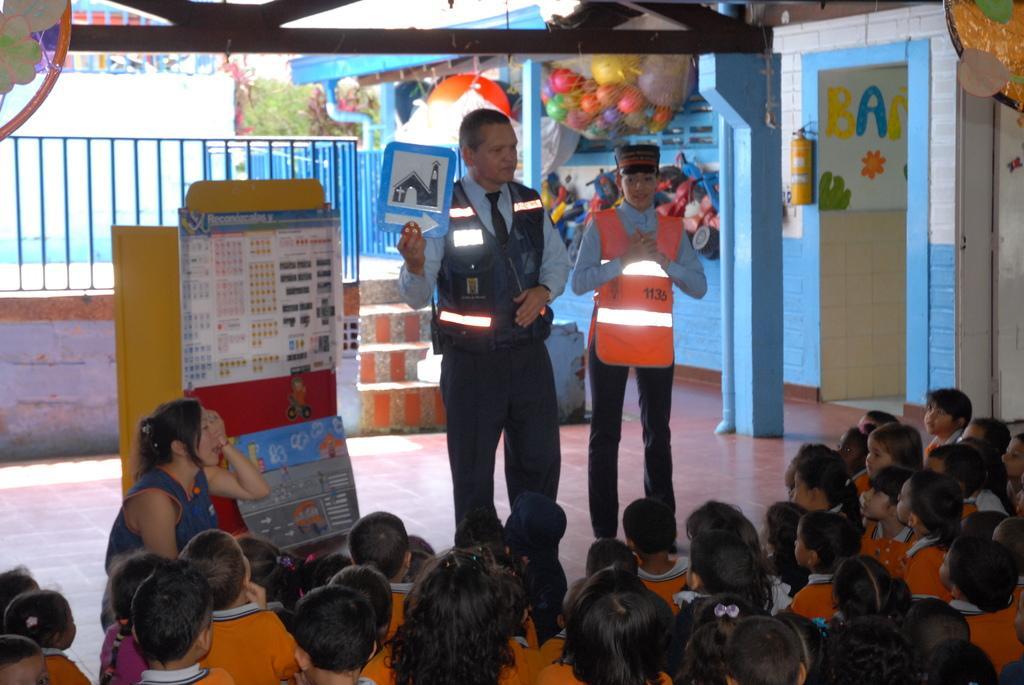Could you give a brief overview of what you see in this image? In this image we can see some group of kids sitting on the floor and paying attention to the policemen who are explaining something and at the background of the image there is fencing, wall and some toys. 